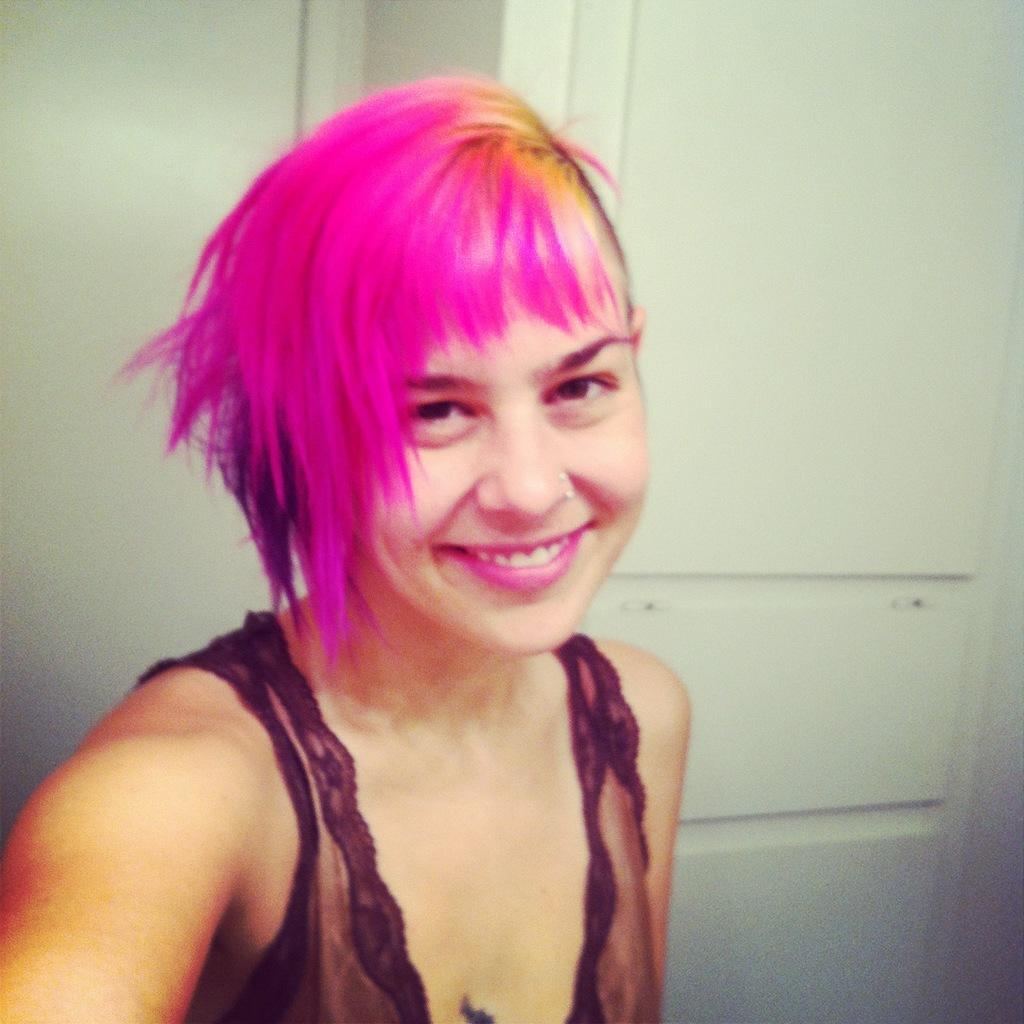Could you give a brief overview of what you see in this image? In the image we can see a girl wearing clothes and the girl is smiling. This is a wall, white in color. 